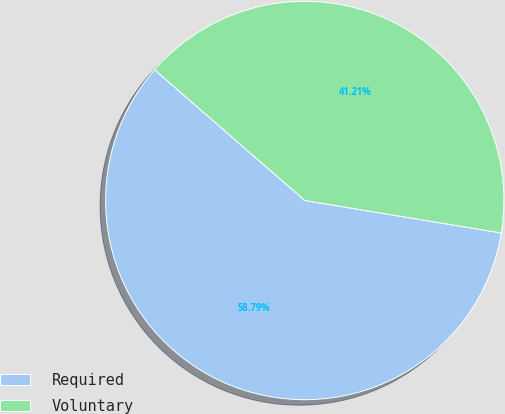<chart> <loc_0><loc_0><loc_500><loc_500><pie_chart><fcel>Required<fcel>Voluntary<nl><fcel>58.79%<fcel>41.21%<nl></chart> 